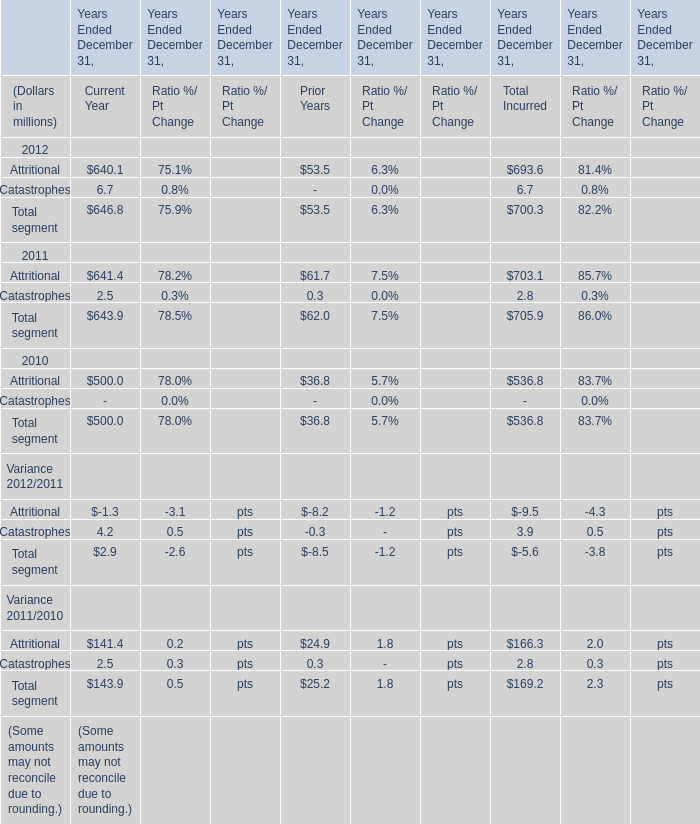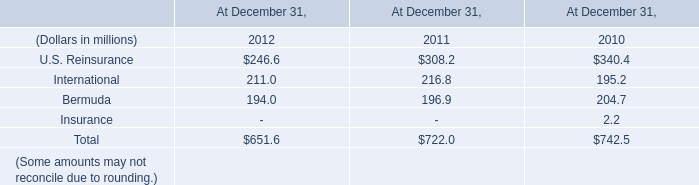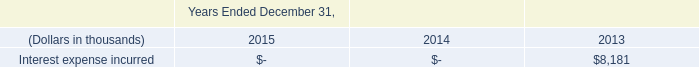what was the percent of the pre-tax expense incurred as part of the early redemption to the redemption amount 
Computations: (7282 / 329897)
Answer: 0.02207. 